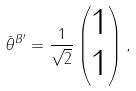Convert formula to latex. <formula><loc_0><loc_0><loc_500><loc_500>\bar { \theta } ^ { B ^ { \prime } } = \frac { 1 } { \sqrt { 2 } } \begin{pmatrix} 1 \\ 1 \\ \end{pmatrix} ,</formula> 